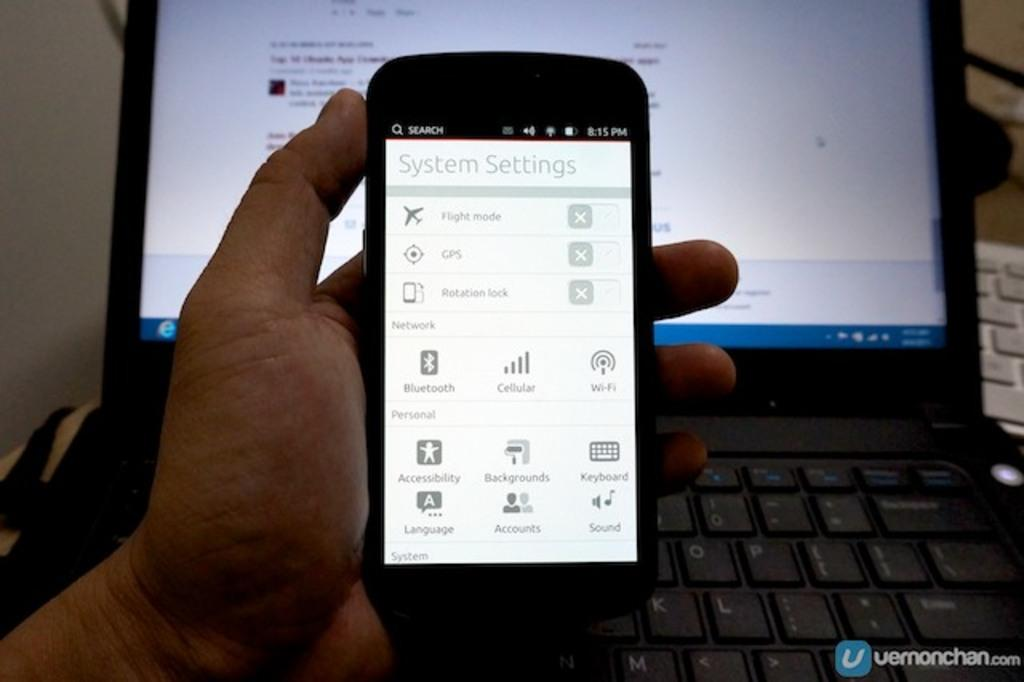<image>
Render a clear and concise summary of the photo. a close up of a cell phone reading System Settings 